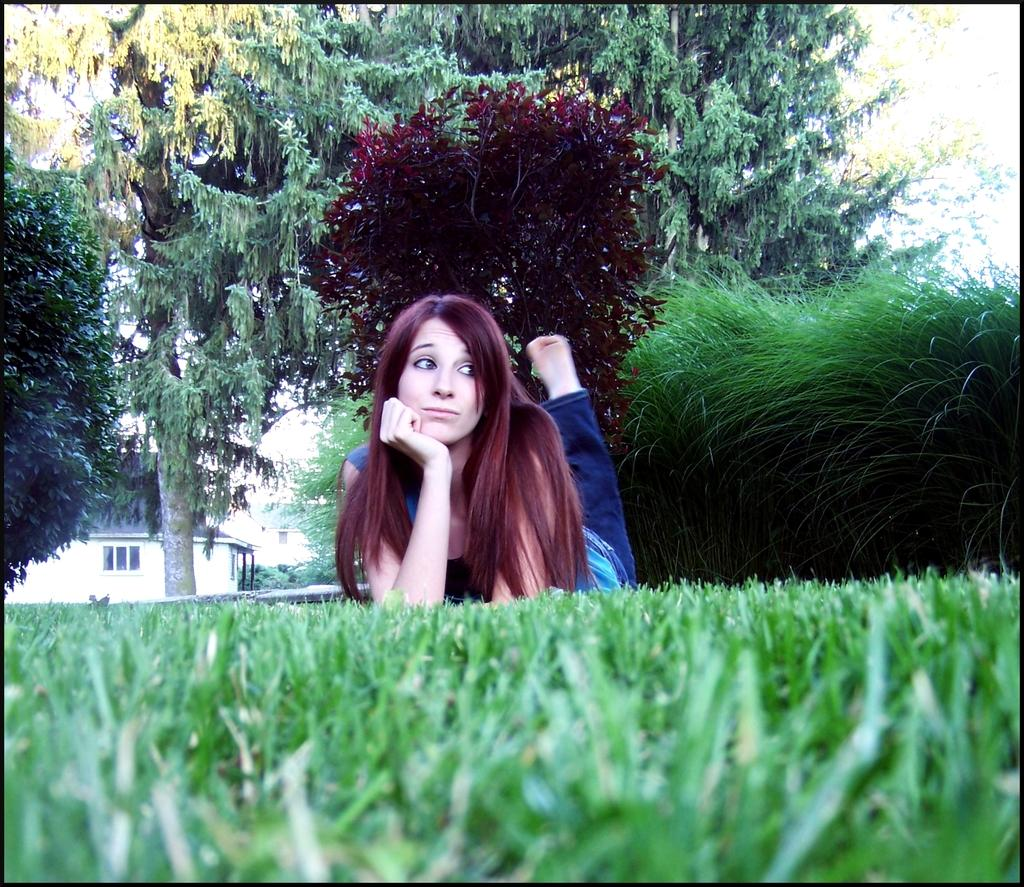What is the main subject of the image? There is a woman lying on the grass in the center of the image. What can be seen in the background of the image? The sky, trees, a building, a wall, a roof, a window, and plants are visible in the background of the image. What type of vegetation is present in the image? Grass is present in the image. How many turkeys can be seen in the image? There are no turkeys present in the image. What is the level of noise in the image? The image does not provide any information about the level of noise or quietness. 